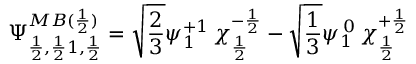<formula> <loc_0><loc_0><loc_500><loc_500>\Psi _ { \frac { 1 } { 2 } , \frac { 1 } { 2 } 1 , \frac { 1 } { 2 } } ^ { M B ( \frac { 1 } { 2 } ) } = \sqrt { \frac { 2 } { 3 } } \psi _ { 1 } ^ { + 1 } \, \chi _ { \frac { 1 } { 2 } } ^ { - \frac { 1 } { 2 } } - \sqrt { \frac { 1 } { 3 } } \psi _ { 1 } ^ { \, 0 } \, \chi _ { \frac { 1 } { 2 } } ^ { + \frac { 1 } { 2 } }</formula> 